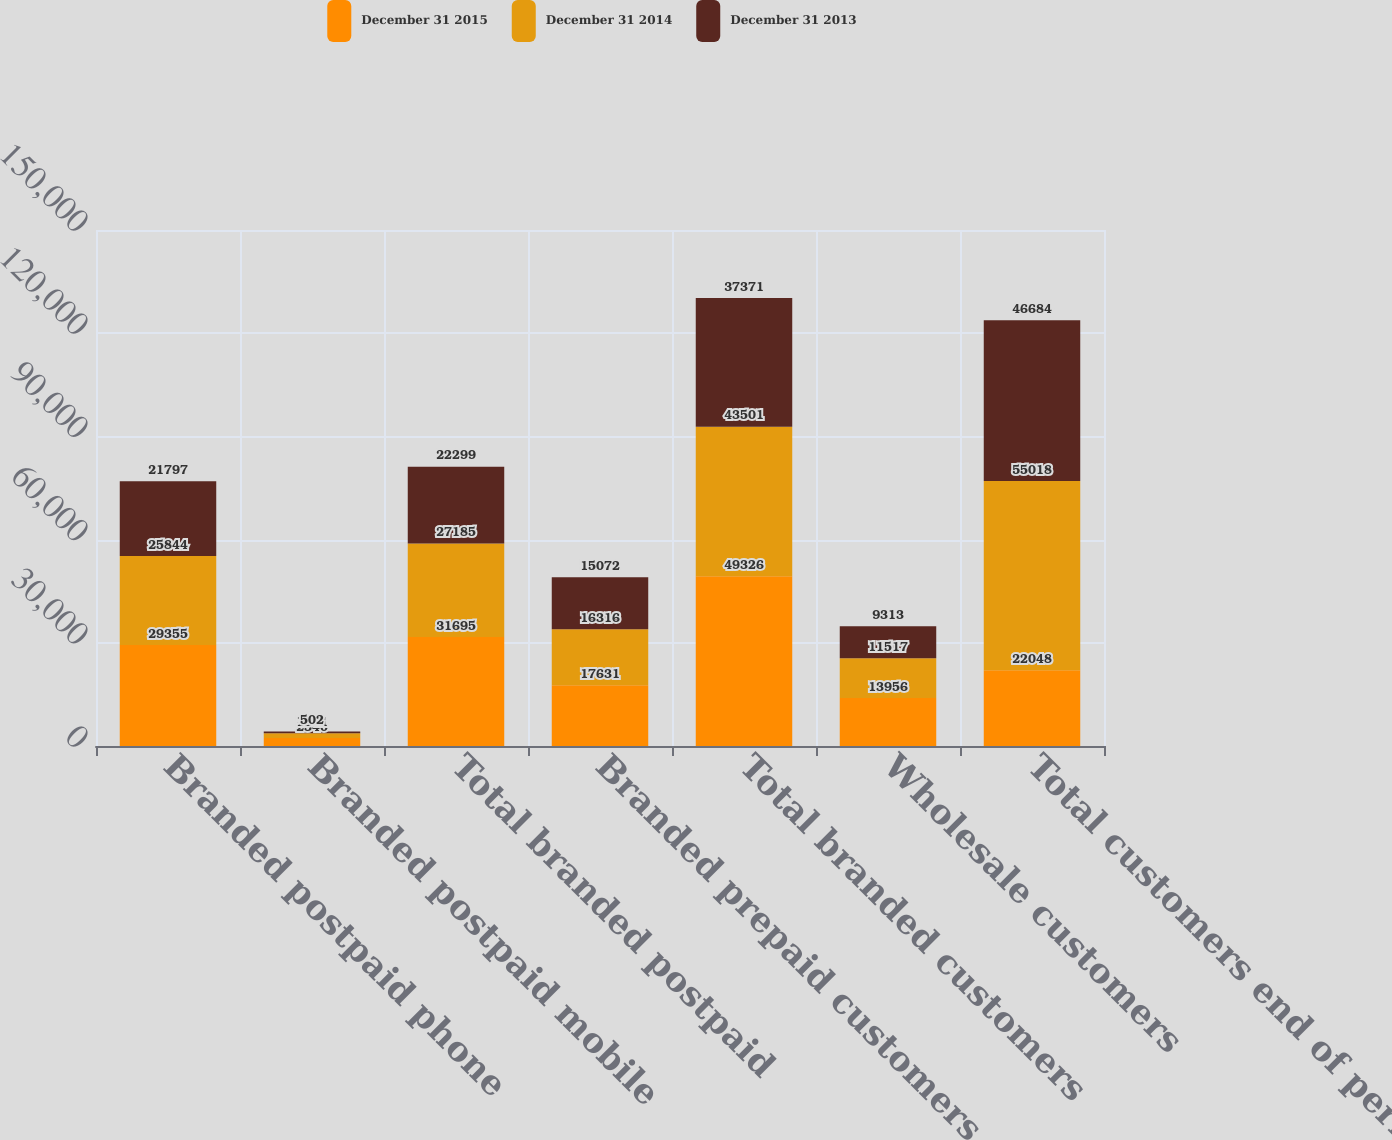<chart> <loc_0><loc_0><loc_500><loc_500><stacked_bar_chart><ecel><fcel>Branded postpaid phone<fcel>Branded postpaid mobile<fcel>Total branded postpaid<fcel>Branded prepaid customers<fcel>Total branded customers<fcel>Wholesale customers<fcel>Total customers end of period<nl><fcel>December 31 2015<fcel>29355<fcel>2340<fcel>31695<fcel>17631<fcel>49326<fcel>13956<fcel>22048<nl><fcel>December 31 2014<fcel>25844<fcel>1341<fcel>27185<fcel>16316<fcel>43501<fcel>11517<fcel>55018<nl><fcel>December 31 2013<fcel>21797<fcel>502<fcel>22299<fcel>15072<fcel>37371<fcel>9313<fcel>46684<nl></chart> 